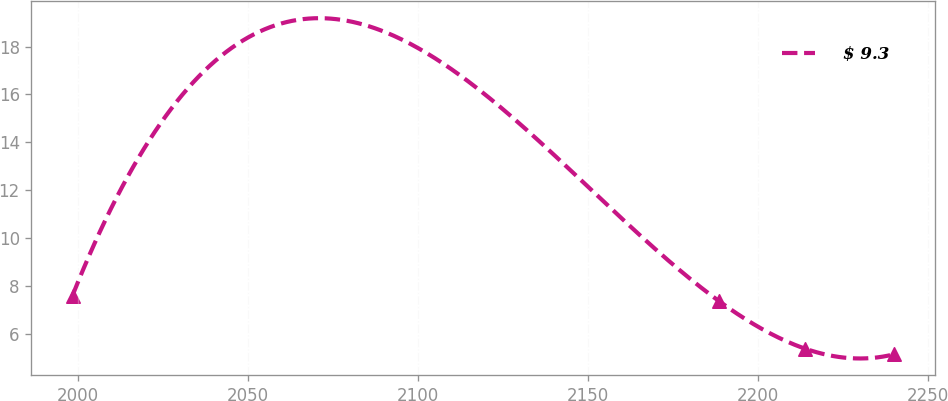<chart> <loc_0><loc_0><loc_500><loc_500><line_chart><ecel><fcel>$ 9.3<nl><fcel>1998.47<fcel>7.59<nl><fcel>2188.6<fcel>7.35<nl><fcel>2213.82<fcel>5.37<nl><fcel>2239.85<fcel>5.13<nl></chart> 